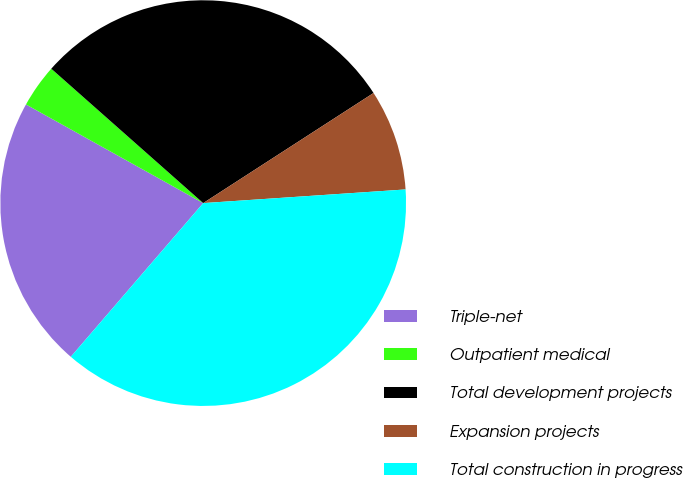Convert chart. <chart><loc_0><loc_0><loc_500><loc_500><pie_chart><fcel>Triple-net<fcel>Outpatient medical<fcel>Total development projects<fcel>Expansion projects<fcel>Total construction in progress<nl><fcel>21.77%<fcel>3.44%<fcel>29.34%<fcel>8.06%<fcel>37.39%<nl></chart> 